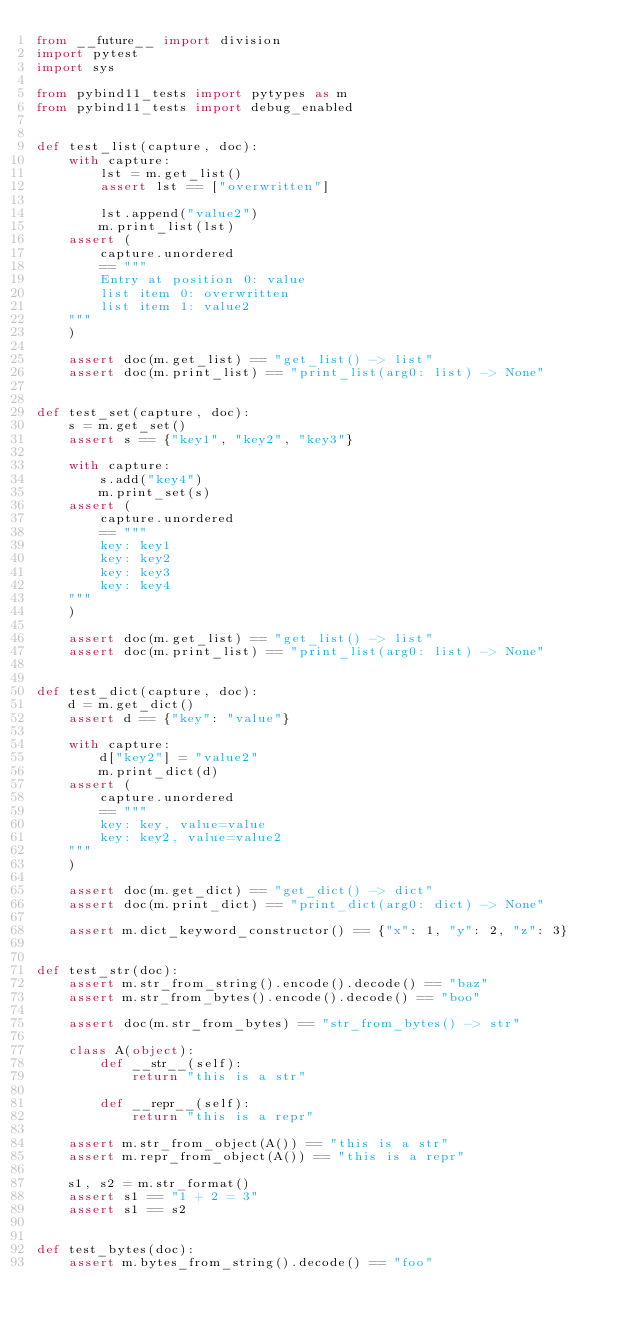<code> <loc_0><loc_0><loc_500><loc_500><_Python_>from __future__ import division
import pytest
import sys

from pybind11_tests import pytypes as m
from pybind11_tests import debug_enabled


def test_list(capture, doc):
    with capture:
        lst = m.get_list()
        assert lst == ["overwritten"]

        lst.append("value2")
        m.print_list(lst)
    assert (
        capture.unordered
        == """
        Entry at position 0: value
        list item 0: overwritten
        list item 1: value2
    """
    )

    assert doc(m.get_list) == "get_list() -> list"
    assert doc(m.print_list) == "print_list(arg0: list) -> None"


def test_set(capture, doc):
    s = m.get_set()
    assert s == {"key1", "key2", "key3"}

    with capture:
        s.add("key4")
        m.print_set(s)
    assert (
        capture.unordered
        == """
        key: key1
        key: key2
        key: key3
        key: key4
    """
    )

    assert doc(m.get_list) == "get_list() -> list"
    assert doc(m.print_list) == "print_list(arg0: list) -> None"


def test_dict(capture, doc):
    d = m.get_dict()
    assert d == {"key": "value"}

    with capture:
        d["key2"] = "value2"
        m.print_dict(d)
    assert (
        capture.unordered
        == """
        key: key, value=value
        key: key2, value=value2
    """
    )

    assert doc(m.get_dict) == "get_dict() -> dict"
    assert doc(m.print_dict) == "print_dict(arg0: dict) -> None"

    assert m.dict_keyword_constructor() == {"x": 1, "y": 2, "z": 3}


def test_str(doc):
    assert m.str_from_string().encode().decode() == "baz"
    assert m.str_from_bytes().encode().decode() == "boo"

    assert doc(m.str_from_bytes) == "str_from_bytes() -> str"

    class A(object):
        def __str__(self):
            return "this is a str"

        def __repr__(self):
            return "this is a repr"

    assert m.str_from_object(A()) == "this is a str"
    assert m.repr_from_object(A()) == "this is a repr"

    s1, s2 = m.str_format()
    assert s1 == "1 + 2 = 3"
    assert s1 == s2


def test_bytes(doc):
    assert m.bytes_from_string().decode() == "foo"</code> 